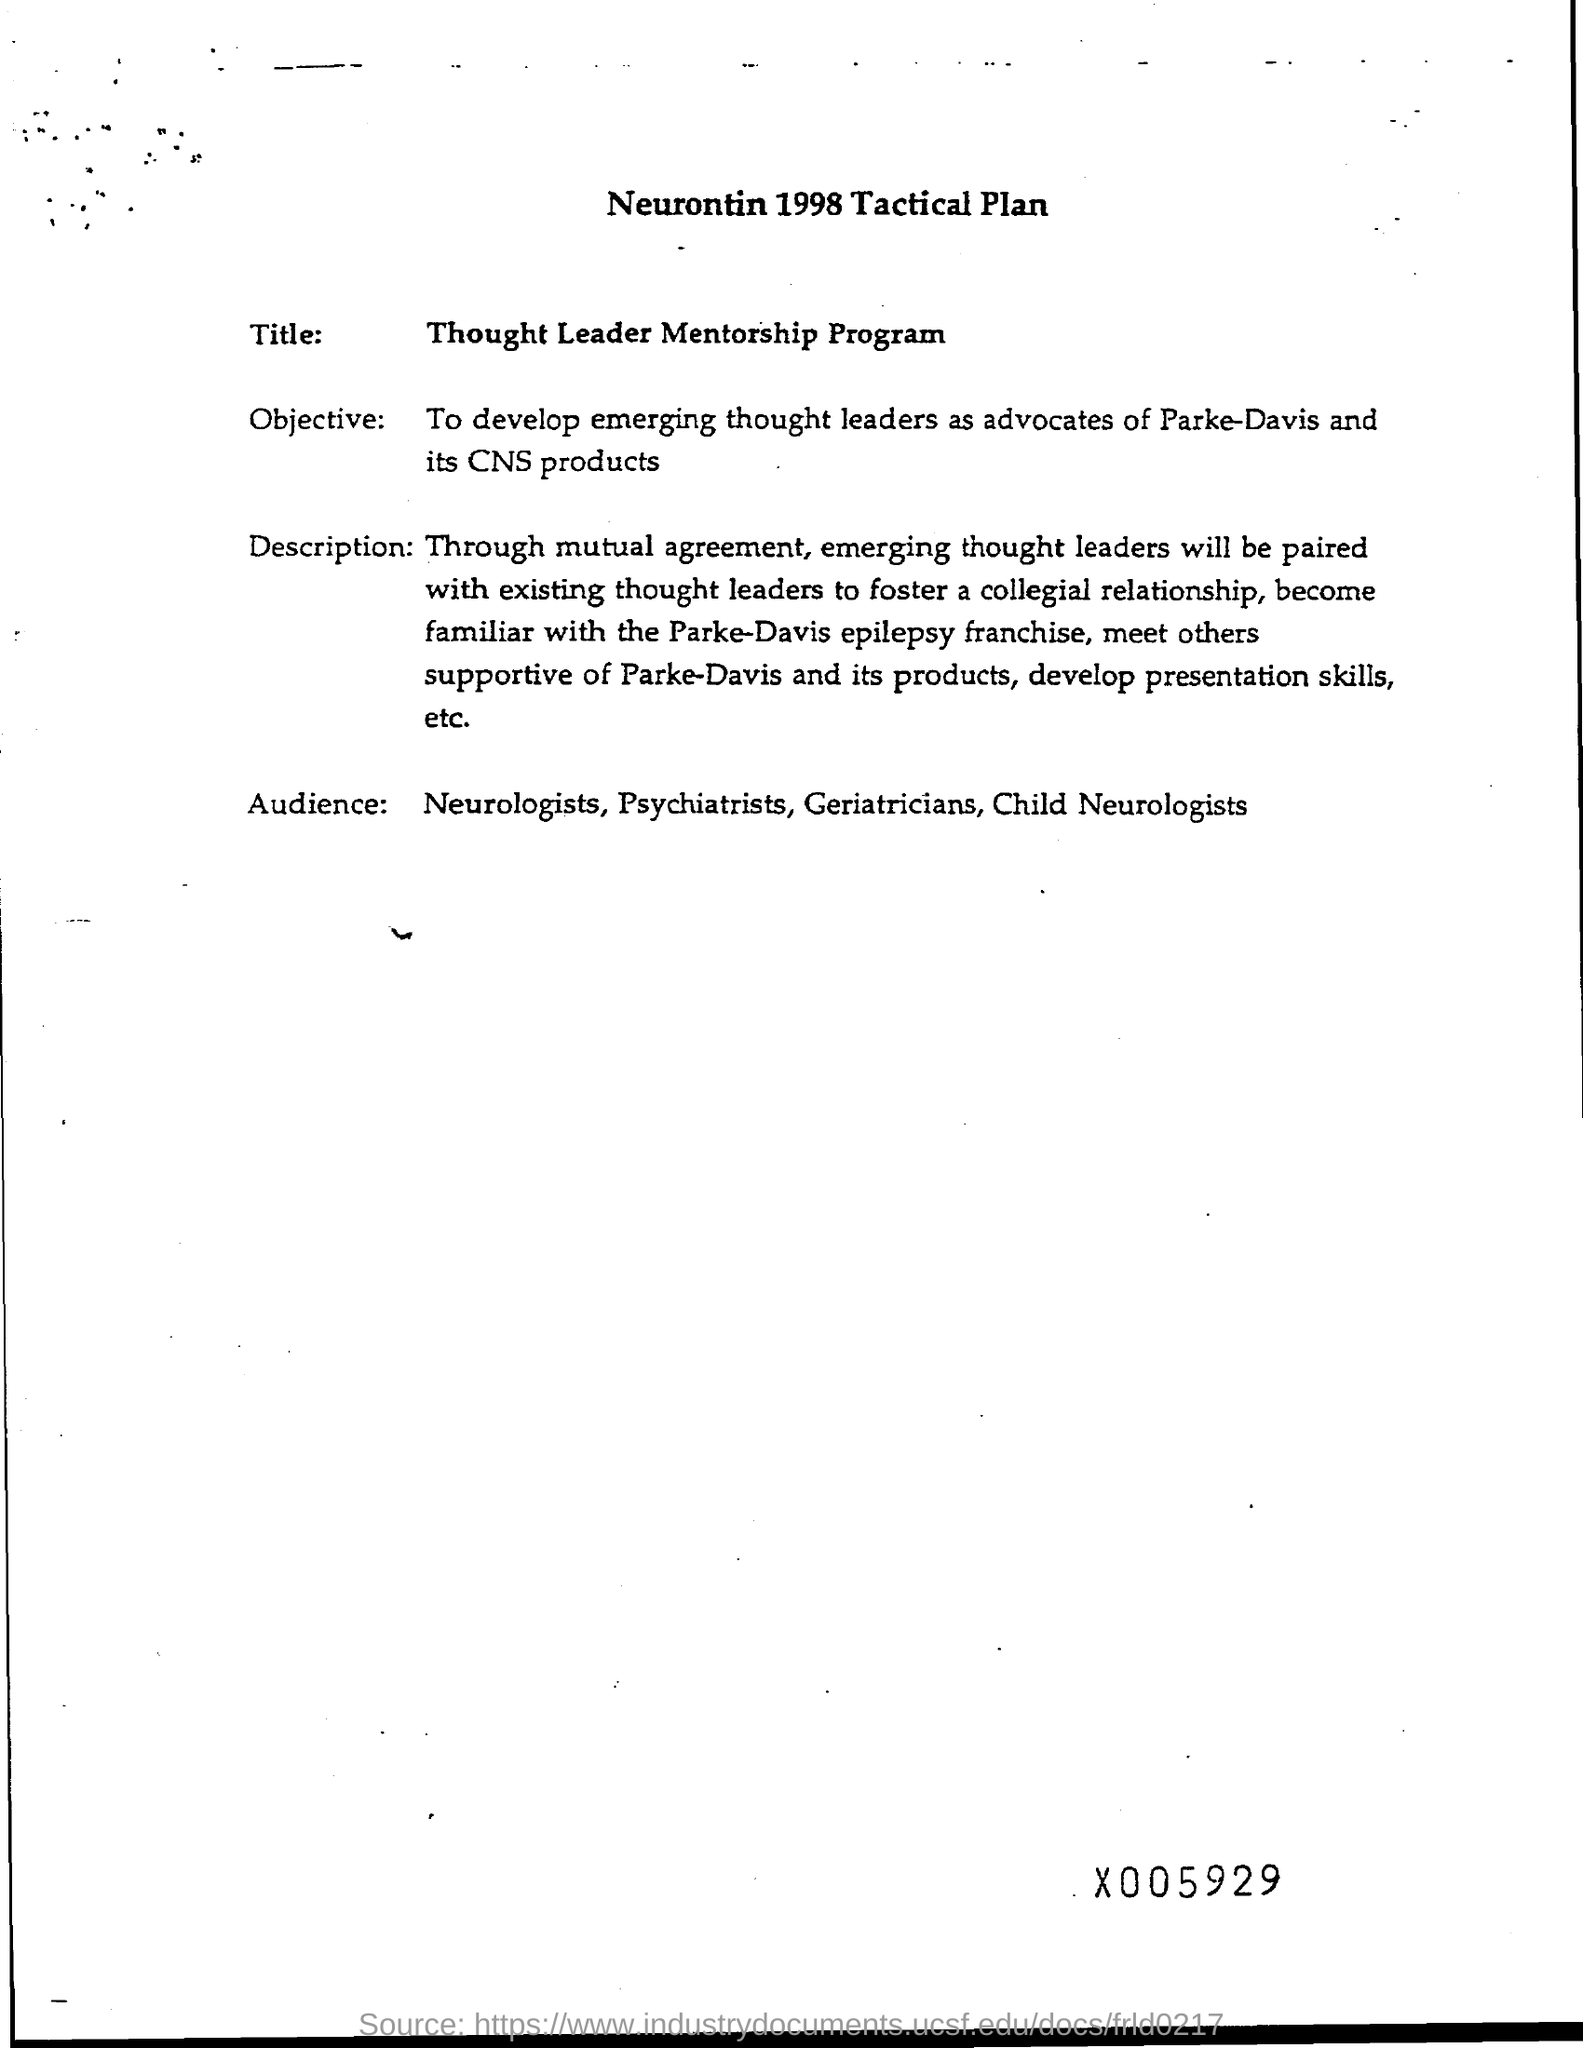Mention a couple of crucial points in this snapshot. Our objective is to cultivate emerging thought leaders as advocates for Parke-Davis and its CNS products. The Title of this program is the "Thought Leader Mentorship Program. The intended audience of the proposed research are neurologists, psychiatrists, geriatricians, and child neurologists. 